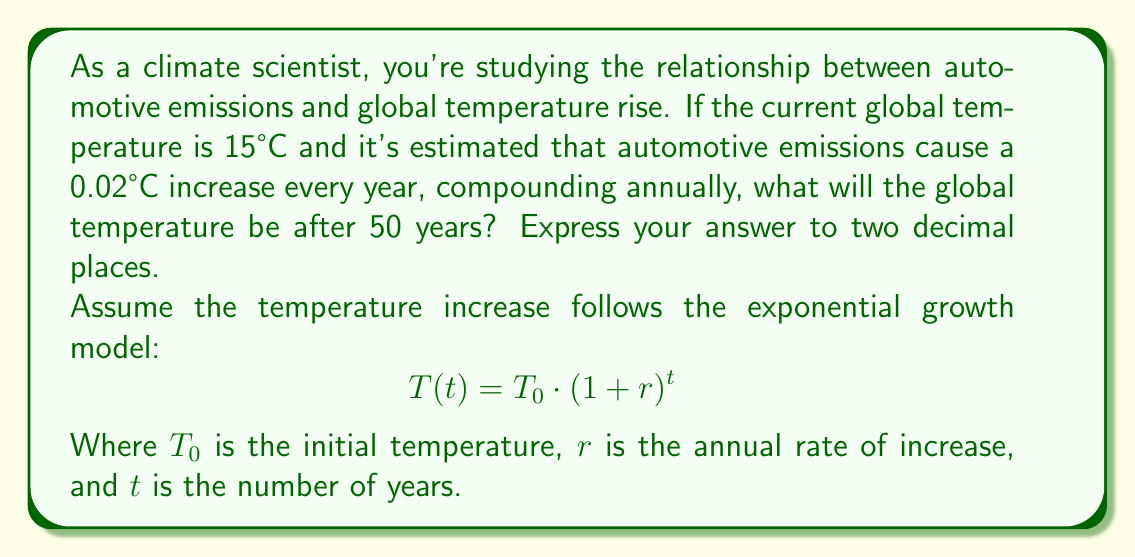Show me your answer to this math problem. To solve this problem, we'll use the exponential growth model:

$$T(t) = T_0 \cdot (1 + r)^t$$

Where:
$T_0 = 15°C$ (initial temperature)
$r = 0.02°C / 15°C = 0.001333$ (annual rate of increase)
$t = 50$ years

Let's substitute these values into the equation:

$$T(50) = 15 \cdot (1 + 0.001333)^{50}$$

Now, we can calculate this step-by-step:

1. Calculate $(1 + 0.001333)^{50}$:
   $(1.001333)^{50} \approx 1.068878$

2. Multiply by the initial temperature:
   $15 \cdot 1.068878 \approx 16.03317$

3. Round to two decimal places:
   $16.03317 \approx 16.03°C$

Therefore, after 50 years, the global temperature is estimated to be 16.03°C.
Answer: 16.03°C 